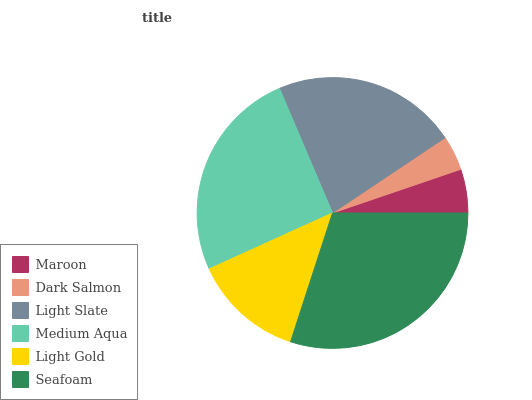Is Dark Salmon the minimum?
Answer yes or no. Yes. Is Seafoam the maximum?
Answer yes or no. Yes. Is Light Slate the minimum?
Answer yes or no. No. Is Light Slate the maximum?
Answer yes or no. No. Is Light Slate greater than Dark Salmon?
Answer yes or no. Yes. Is Dark Salmon less than Light Slate?
Answer yes or no. Yes. Is Dark Salmon greater than Light Slate?
Answer yes or no. No. Is Light Slate less than Dark Salmon?
Answer yes or no. No. Is Light Slate the high median?
Answer yes or no. Yes. Is Light Gold the low median?
Answer yes or no. Yes. Is Dark Salmon the high median?
Answer yes or no. No. Is Light Slate the low median?
Answer yes or no. No. 